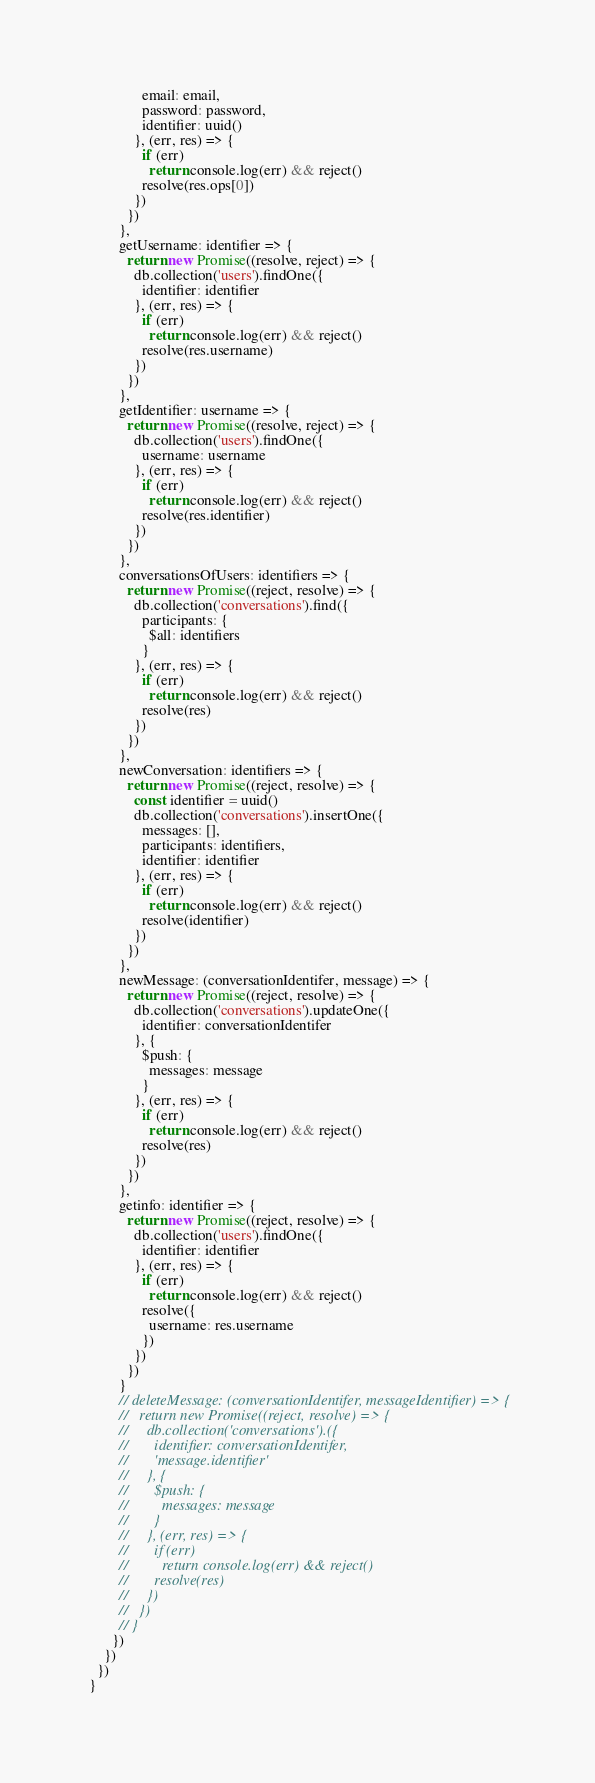<code> <loc_0><loc_0><loc_500><loc_500><_JavaScript_>              email: email,
              password: password,
              identifier: uuid()
            }, (err, res) => {
              if (err)
                return console.log(err) && reject()
              resolve(res.ops[0])
            })
          })
        },
        getUsername: identifier => {
          return new Promise((resolve, reject) => {
            db.collection('users').findOne({
              identifier: identifier
            }, (err, res) => {
              if (err)
                return console.log(err) && reject()
              resolve(res.username)
            })
          })
        },
        getIdentifier: username => {
          return new Promise((resolve, reject) => {
            db.collection('users').findOne({
              username: username
            }, (err, res) => {
              if (err)
                return console.log(err) && reject()
              resolve(res.identifier)
            })
          })
        },
        conversationsOfUsers: identifiers => {
          return new Promise((reject, resolve) => {
            db.collection('conversations').find({
              participants: {
                $all: identifiers
              }
            }, (err, res) => {
              if (err)
                return console.log(err) && reject()
              resolve(res)
            })
          })
        },
        newConversation: identifiers => {
          return new Promise((reject, resolve) => {
            const identifier = uuid()
            db.collection('conversations').insertOne({
              messages: [],
              participants: identifiers,
              identifier: identifier
            }, (err, res) => {
              if (err)
                return console.log(err) && reject()
              resolve(identifier)
            })
          })
        },
        newMessage: (conversationIdentifer, message) => {
          return new Promise((reject, resolve) => {
            db.collection('conversations').updateOne({
              identifier: conversationIdentifer
            }, {
              $push: {
                messages: message
              }
            }, (err, res) => {
              if (err)
                return console.log(err) && reject()
              resolve(res)
            })
          })
        },
        getinfo: identifier => {
          return new Promise((reject, resolve) => {
            db.collection('users').findOne({
              identifier: identifier
            }, (err, res) => {
              if (err)
                return console.log(err) && reject()
              resolve({
                username: res.username
              })
            })
          })
        }
        // deleteMessage: (conversationIdentifer, messageIdentifier) => {
        //   return new Promise((reject, resolve) => {
        //     db.collection('conversations').({
        //       identifier: conversationIdentifer,
        //       'message.identifier'
        //     }, {
        //       $push: {
        //         messages: message
        //       }
        //     }, (err, res) => {
        //       if (err)
        //         return console.log(err) && reject()
        //       resolve(res)
        //     })
        //   })
        // }
      })
    })
  })
}
</code> 